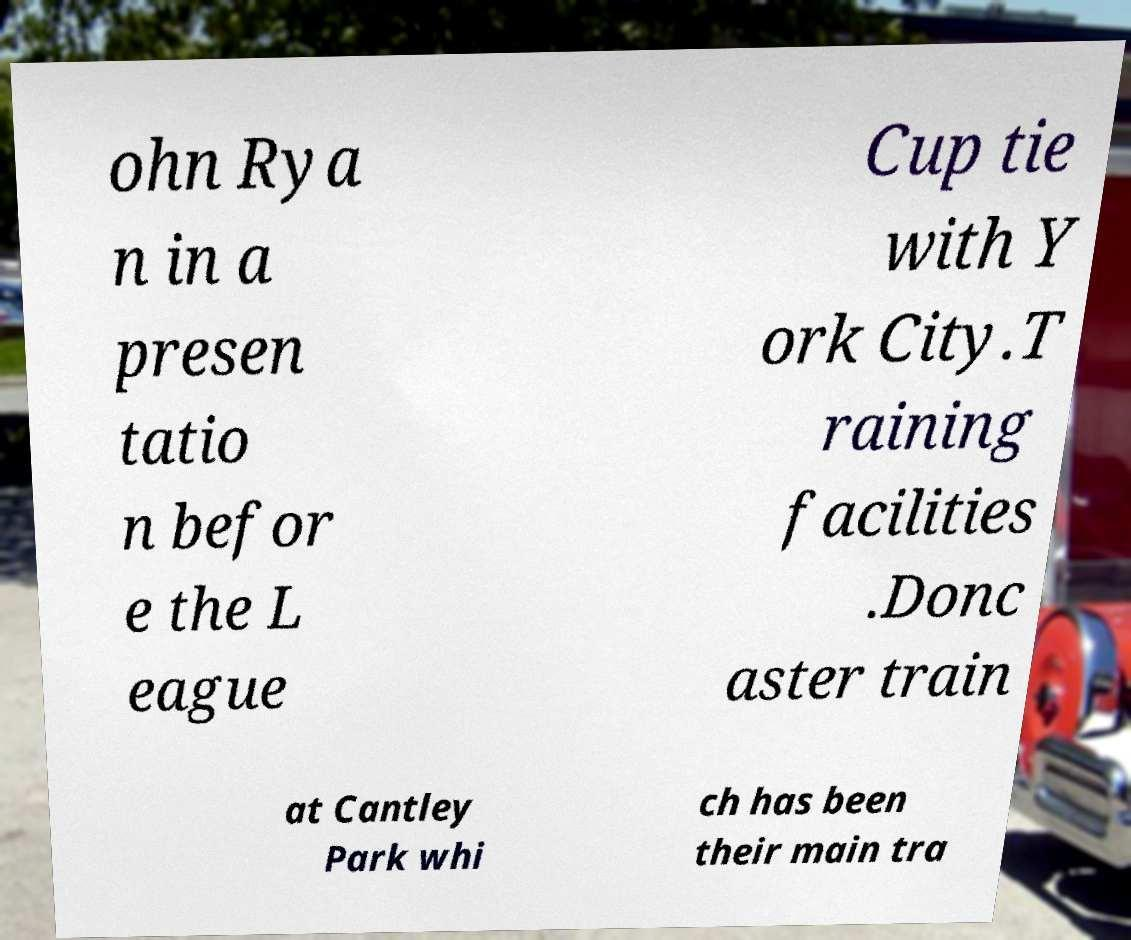Could you extract and type out the text from this image? ohn Rya n in a presen tatio n befor e the L eague Cup tie with Y ork City.T raining facilities .Donc aster train at Cantley Park whi ch has been their main tra 